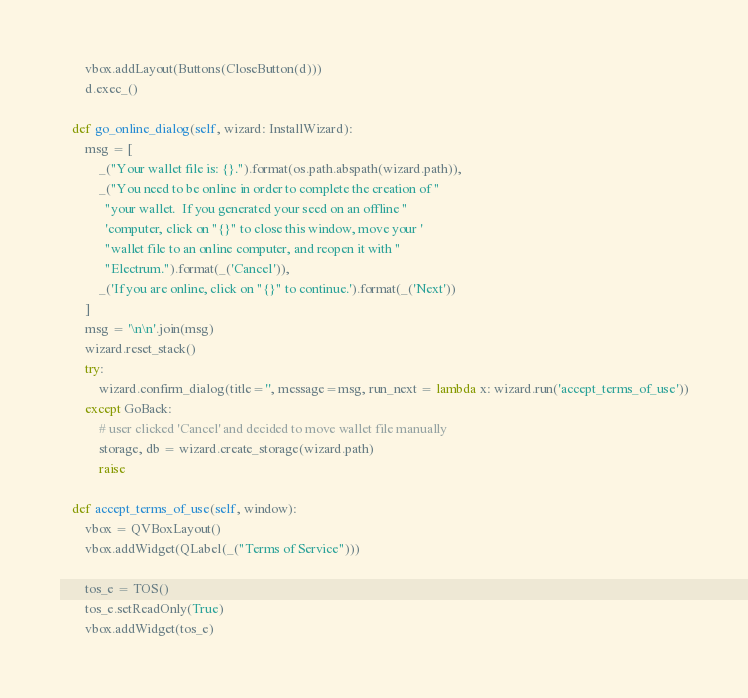<code> <loc_0><loc_0><loc_500><loc_500><_Python_>        vbox.addLayout(Buttons(CloseButton(d)))
        d.exec_()

    def go_online_dialog(self, wizard: InstallWizard):
        msg = [
            _("Your wallet file is: {}.").format(os.path.abspath(wizard.path)),
            _("You need to be online in order to complete the creation of "
              "your wallet.  If you generated your seed on an offline "
              'computer, click on "{}" to close this window, move your '
              "wallet file to an online computer, and reopen it with "
              "Electrum.").format(_('Cancel')),
            _('If you are online, click on "{}" to continue.').format(_('Next'))
        ]
        msg = '\n\n'.join(msg)
        wizard.reset_stack()
        try:
            wizard.confirm_dialog(title='', message=msg, run_next = lambda x: wizard.run('accept_terms_of_use'))
        except GoBack:
            # user clicked 'Cancel' and decided to move wallet file manually
            storage, db = wizard.create_storage(wizard.path)
            raise

    def accept_terms_of_use(self, window):
        vbox = QVBoxLayout()
        vbox.addWidget(QLabel(_("Terms of Service")))

        tos_e = TOS()
        tos_e.setReadOnly(True)
        vbox.addWidget(tos_e)</code> 